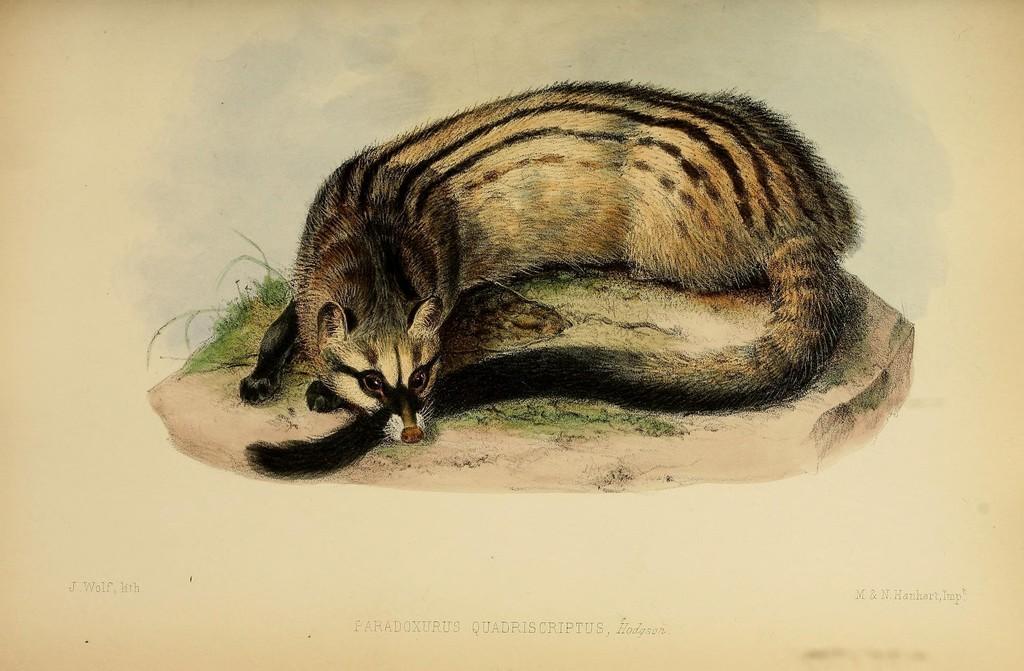Please provide a concise description of this image. In this image we can see the picture of an animal lying on the ground and grass. 